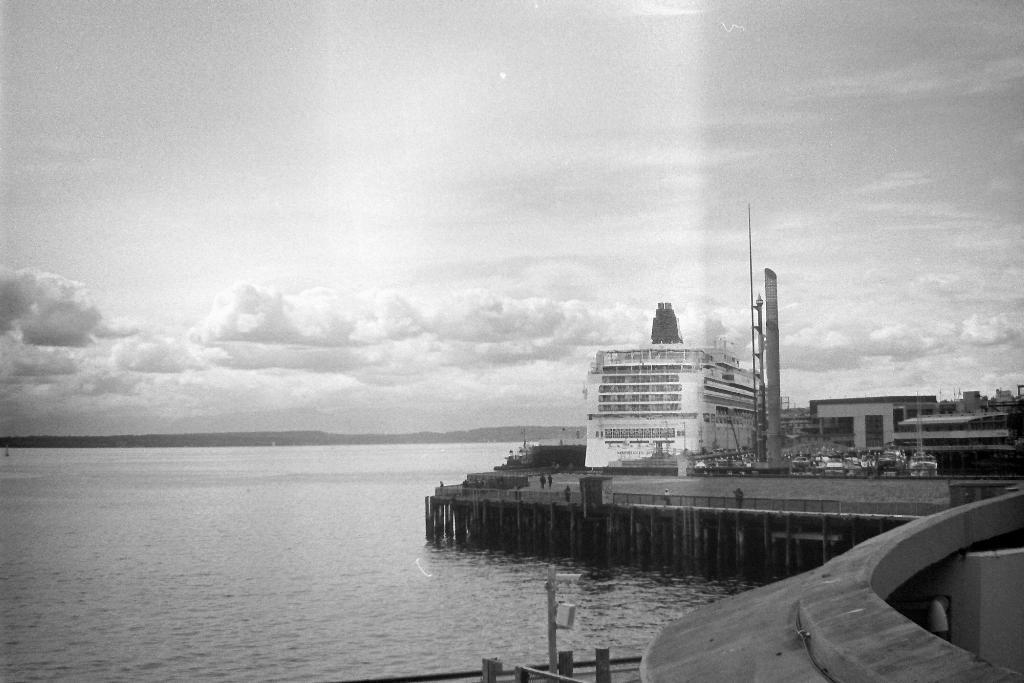What type of structures can be seen in the image? There are buildings in the image. What else is present in the image besides buildings? There are vehicles, a bridge, and poles visible in the image. What natural element can be seen in the image? Water is visible in the image. What is the color scheme of the image? The image is in black and white. What type of yam is being cooked on the bridge in the image? There is no yam or cooking activity present in the image; it features buildings, vehicles, a bridge, poles, and water in a black and white color scheme. How does the smoke from the yam affect the visibility of the vehicles in the image? There is no smoke or yam present in the image, so it cannot affect the visibility of the vehicles. 